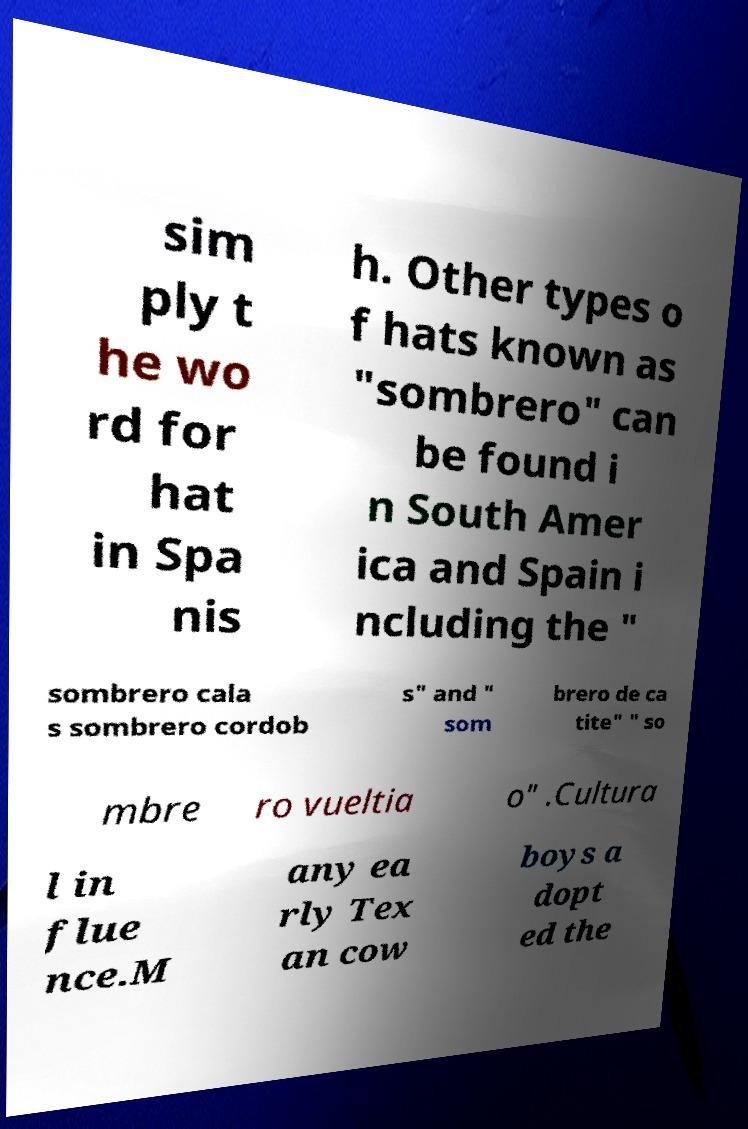Please read and relay the text visible in this image. What does it say? sim ply t he wo rd for hat in Spa nis h. Other types o f hats known as "sombrero" can be found i n South Amer ica and Spain i ncluding the " sombrero cala s sombrero cordob s" and " som brero de ca tite" " so mbre ro vueltia o" .Cultura l in flue nce.M any ea rly Tex an cow boys a dopt ed the 